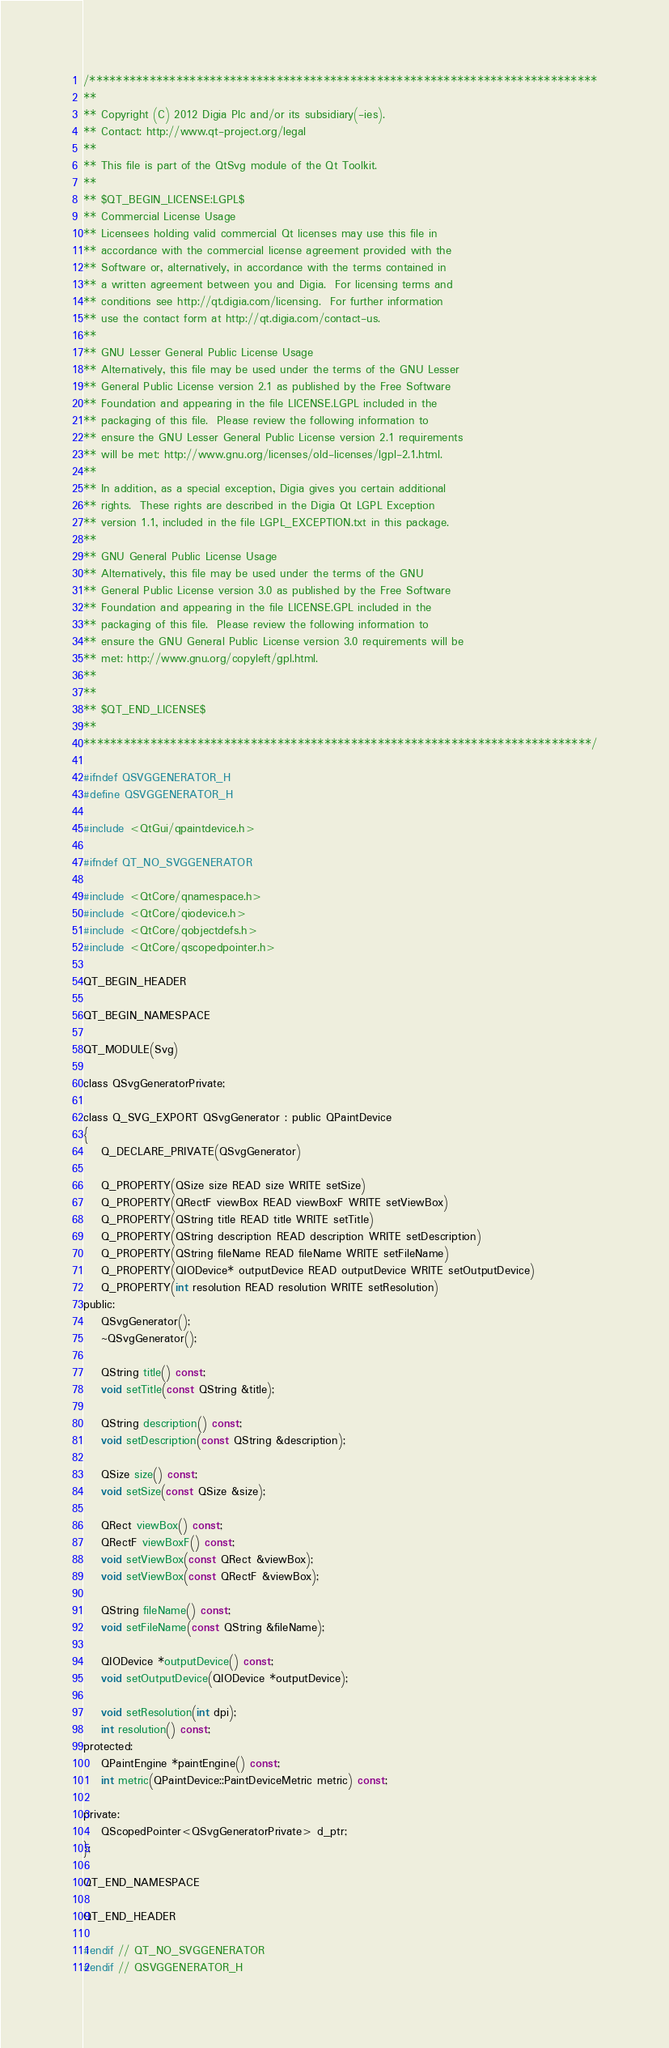Convert code to text. <code><loc_0><loc_0><loc_500><loc_500><_C_>/****************************************************************************
**
** Copyright (C) 2012 Digia Plc and/or its subsidiary(-ies).
** Contact: http://www.qt-project.org/legal
**
** This file is part of the QtSvg module of the Qt Toolkit.
**
** $QT_BEGIN_LICENSE:LGPL$
** Commercial License Usage
** Licensees holding valid commercial Qt licenses may use this file in
** accordance with the commercial license agreement provided with the
** Software or, alternatively, in accordance with the terms contained in
** a written agreement between you and Digia.  For licensing terms and
** conditions see http://qt.digia.com/licensing.  For further information
** use the contact form at http://qt.digia.com/contact-us.
**
** GNU Lesser General Public License Usage
** Alternatively, this file may be used under the terms of the GNU Lesser
** General Public License version 2.1 as published by the Free Software
** Foundation and appearing in the file LICENSE.LGPL included in the
** packaging of this file.  Please review the following information to
** ensure the GNU Lesser General Public License version 2.1 requirements
** will be met: http://www.gnu.org/licenses/old-licenses/lgpl-2.1.html.
**
** In addition, as a special exception, Digia gives you certain additional
** rights.  These rights are described in the Digia Qt LGPL Exception
** version 1.1, included in the file LGPL_EXCEPTION.txt in this package.
**
** GNU General Public License Usage
** Alternatively, this file may be used under the terms of the GNU
** General Public License version 3.0 as published by the Free Software
** Foundation and appearing in the file LICENSE.GPL included in the
** packaging of this file.  Please review the following information to
** ensure the GNU General Public License version 3.0 requirements will be
** met: http://www.gnu.org/copyleft/gpl.html.
**
**
** $QT_END_LICENSE$
**
****************************************************************************/

#ifndef QSVGGENERATOR_H
#define QSVGGENERATOR_H

#include <QtGui/qpaintdevice.h>

#ifndef QT_NO_SVGGENERATOR

#include <QtCore/qnamespace.h>
#include <QtCore/qiodevice.h>
#include <QtCore/qobjectdefs.h>
#include <QtCore/qscopedpointer.h>

QT_BEGIN_HEADER

QT_BEGIN_NAMESPACE

QT_MODULE(Svg)

class QSvgGeneratorPrivate;

class Q_SVG_EXPORT QSvgGenerator : public QPaintDevice
{
    Q_DECLARE_PRIVATE(QSvgGenerator)

    Q_PROPERTY(QSize size READ size WRITE setSize)
    Q_PROPERTY(QRectF viewBox READ viewBoxF WRITE setViewBox)
    Q_PROPERTY(QString title READ title WRITE setTitle)
    Q_PROPERTY(QString description READ description WRITE setDescription)
    Q_PROPERTY(QString fileName READ fileName WRITE setFileName)
    Q_PROPERTY(QIODevice* outputDevice READ outputDevice WRITE setOutputDevice)
    Q_PROPERTY(int resolution READ resolution WRITE setResolution)
public:
    QSvgGenerator();
    ~QSvgGenerator();

    QString title() const;
    void setTitle(const QString &title);

    QString description() const;
    void setDescription(const QString &description);

    QSize size() const;
    void setSize(const QSize &size);

    QRect viewBox() const;
    QRectF viewBoxF() const;
    void setViewBox(const QRect &viewBox);
    void setViewBox(const QRectF &viewBox);

    QString fileName() const;
    void setFileName(const QString &fileName);

    QIODevice *outputDevice() const;
    void setOutputDevice(QIODevice *outputDevice);

    void setResolution(int dpi);
    int resolution() const;
protected:
    QPaintEngine *paintEngine() const;
    int metric(QPaintDevice::PaintDeviceMetric metric) const;

private:
    QScopedPointer<QSvgGeneratorPrivate> d_ptr;
};

QT_END_NAMESPACE

QT_END_HEADER

#endif // QT_NO_SVGGENERATOR
#endif // QSVGGENERATOR_H
</code> 